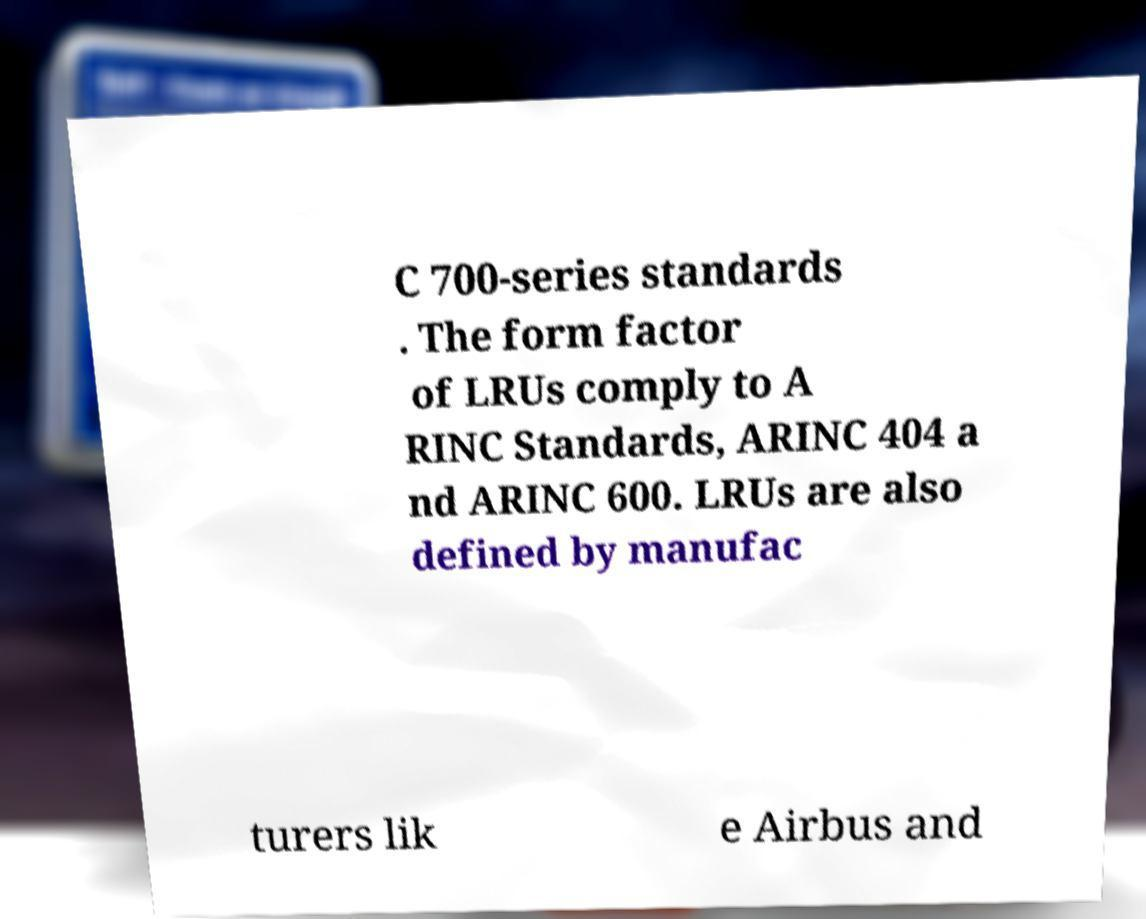Could you assist in decoding the text presented in this image and type it out clearly? C 700-series standards . The form factor of LRUs comply to A RINC Standards, ARINC 404 a nd ARINC 600. LRUs are also defined by manufac turers lik e Airbus and 